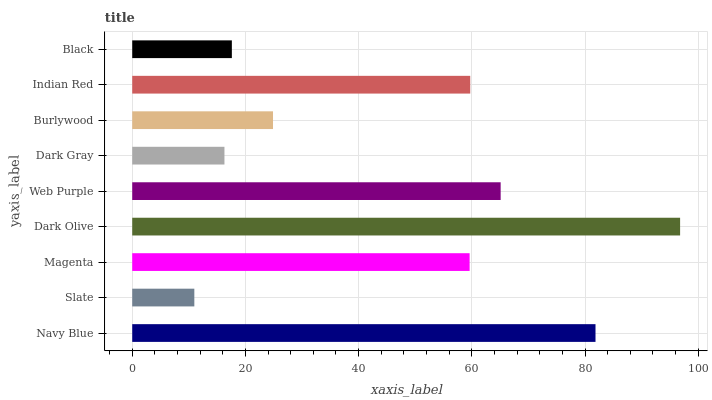Is Slate the minimum?
Answer yes or no. Yes. Is Dark Olive the maximum?
Answer yes or no. Yes. Is Magenta the minimum?
Answer yes or no. No. Is Magenta the maximum?
Answer yes or no. No. Is Magenta greater than Slate?
Answer yes or no. Yes. Is Slate less than Magenta?
Answer yes or no. Yes. Is Slate greater than Magenta?
Answer yes or no. No. Is Magenta less than Slate?
Answer yes or no. No. Is Magenta the high median?
Answer yes or no. Yes. Is Magenta the low median?
Answer yes or no. Yes. Is Navy Blue the high median?
Answer yes or no. No. Is Navy Blue the low median?
Answer yes or no. No. 